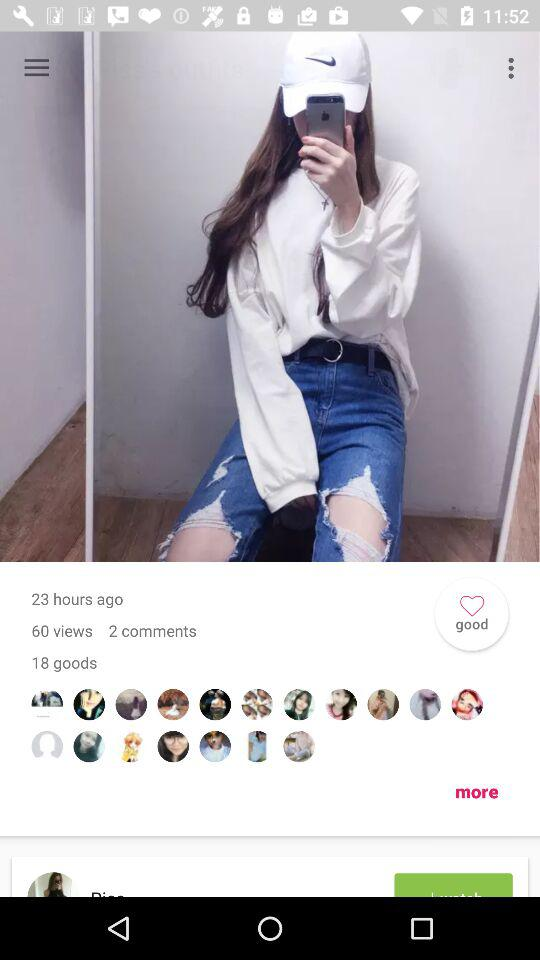What are the total views of the photo? There are 60 views. 